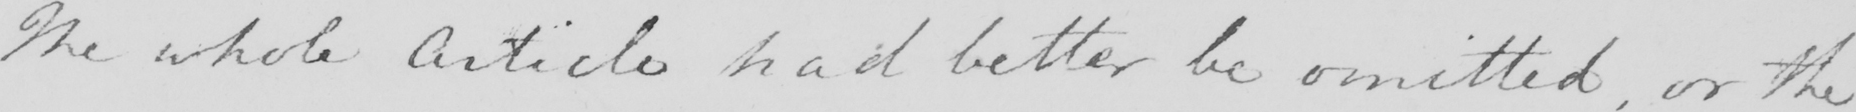Please transcribe the handwritten text in this image. The whole Article had better be omitted , or the 